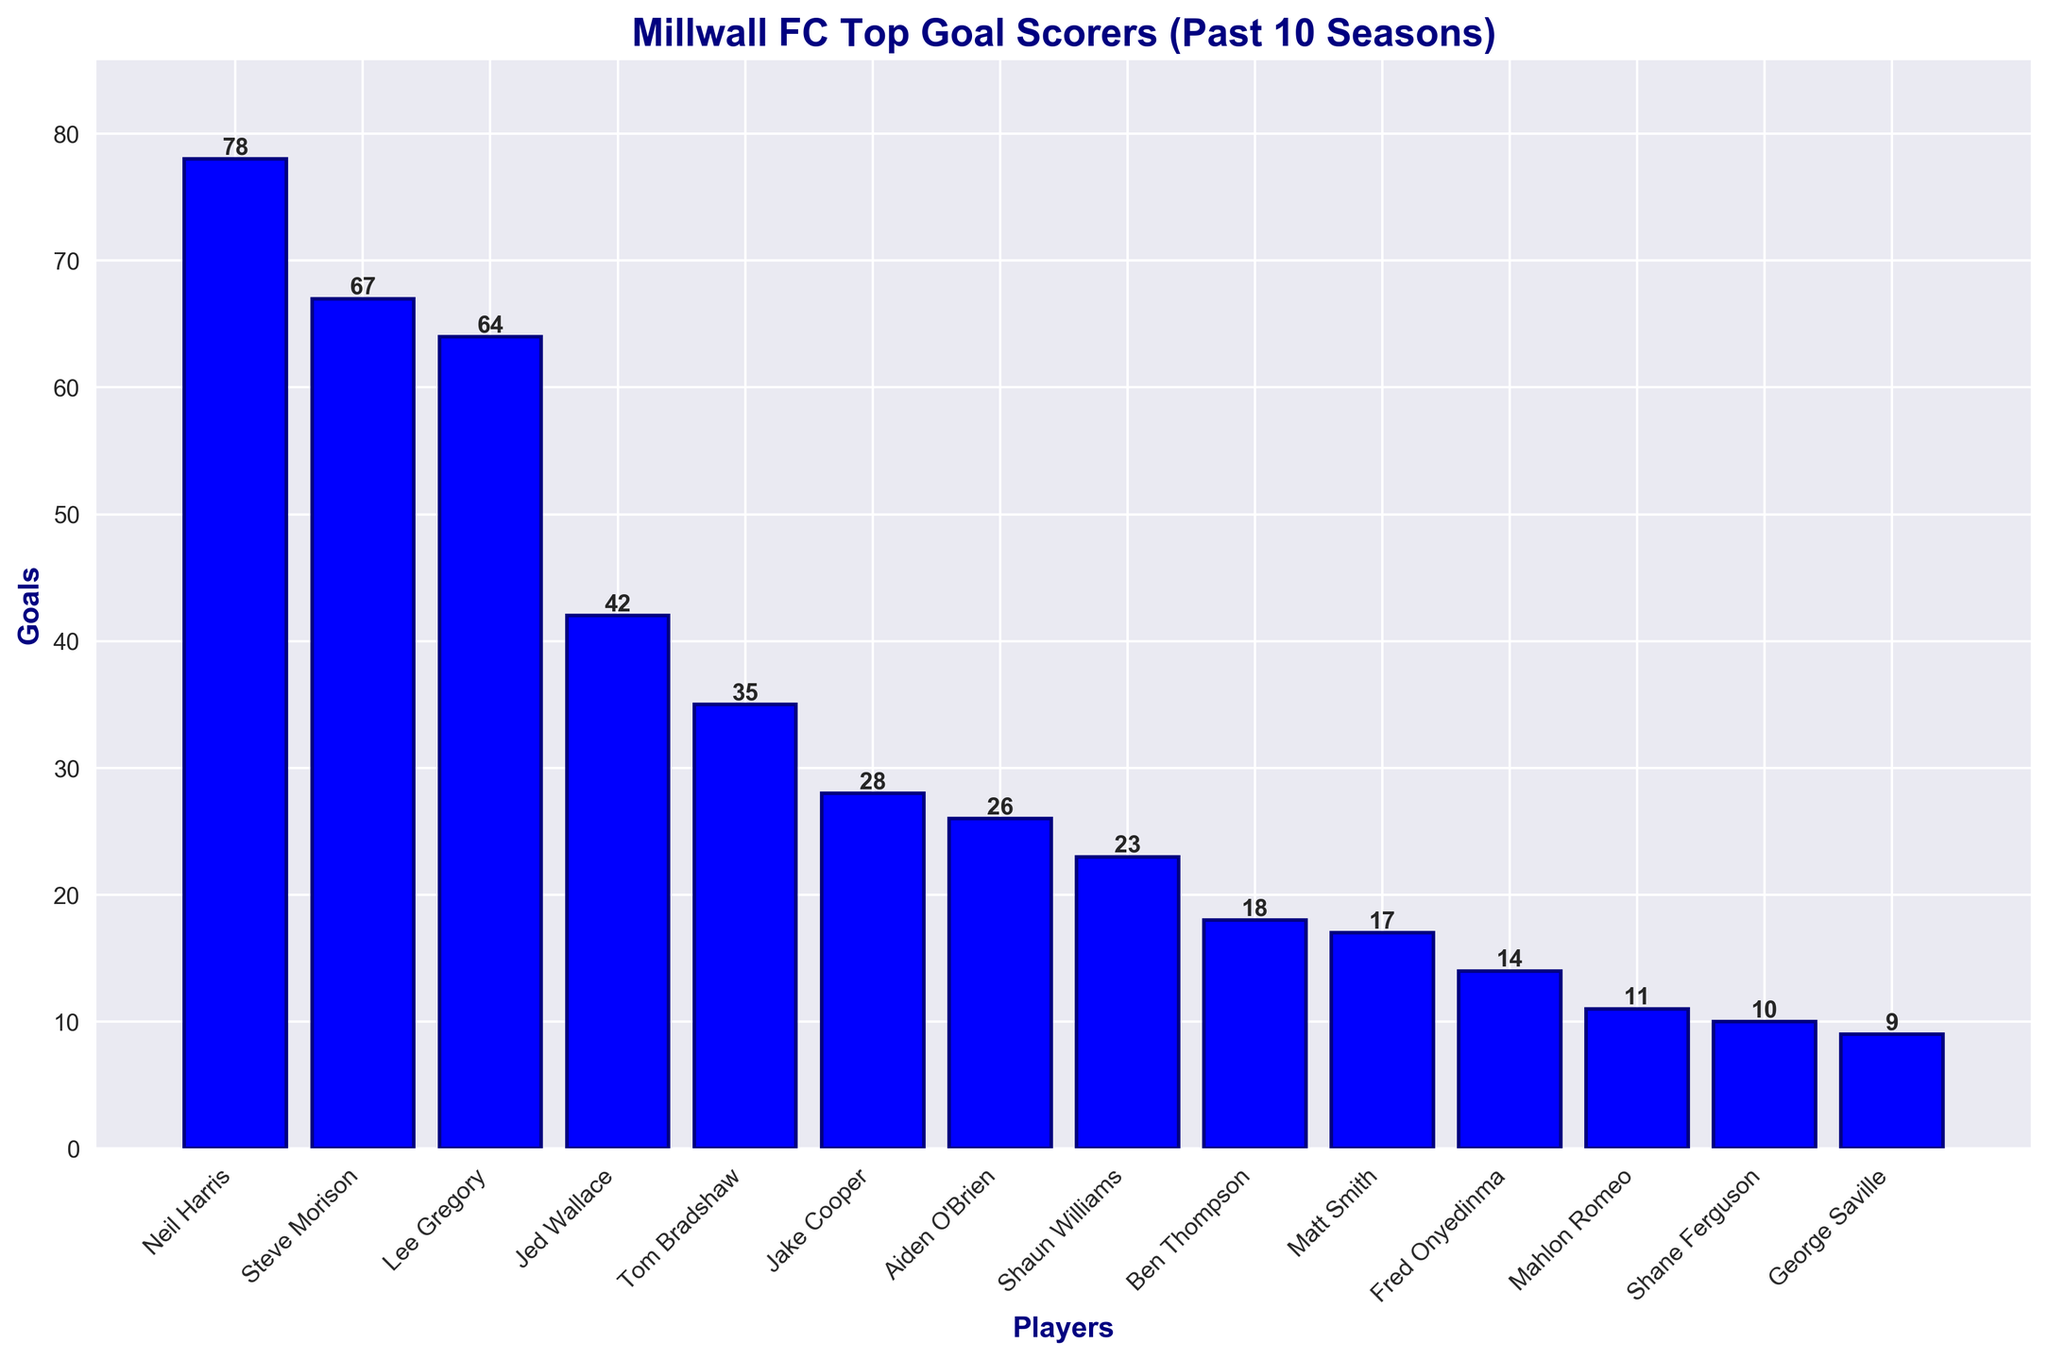What is the total number of goals scored by the top three goal scorers? To find the total number of goals scored by the top three goal scorers, sum the goals of Neil Harris, Steve Morison, and Lee Gregory: 78 + 67 + 64 = 209
Answer: 209 Who is the top goal scorer? The top goal scorer is the player with the highest bar. Neil Harris has the tallest bar with 78 goals.
Answer: Neil Harris How many goals does the player with the second-highest goals score compared to the fourth-highest? The second-highest scorer, Steve Morison, scored 67 goals, and the fourth-highest scorer, Jed Wallace, scored 42 goals. The difference is 67 - 42 = 25.
Answer: 25 What is the average number of goals scored by the players listed? Sum the goals scored by all players and divide by the number of players. Total goals: 78 + 67 + 64 + 42 + 35 + 28 + 26 + 23 + 18 + 17 + 14 + 11 + 10 + 9 = 442. Number of players: 14. Average = 442 / 14 = 31.57
Answer: 31.57 Which players scored fewer than 20 goals? From the bar chart, the players who scored fewer than 20 goals are Ben Thompson, Matt Smith, Fred Onyedinma, Mahlon Romeo, Shane Ferguson, and George Saville.
Answer: Ben Thompson, Matt Smith, Fred Onyedinma, Mahlon Romeo, Shane Ferguson, George Saville What is the difference in the number of goals between the players with the third-highest and the sixth-highest scores? The third-highest scorer, Lee Gregory, has 64 goals, and the sixth-highest scorer, Jake Cooper, has 28 goals. The difference is 64 - 28 = 36.
Answer: 36 Which player's bar is just to the right of Neil Harris in the plot? The bar just to the right of Neil Harris's bar represents Steve Morison, who scored 67 goals.
Answer: Steve Morison How many players scored more than 50 goals? By inspecting the bars, the players who scored more than 50 goals are Neil Harris, Steve Morison, and Lee Gregory. There are 3 players.
Answer: 3 What is the range of goals scored by the players? The range is the difference between the highest and lowest goal counts. The highest is 78 (Neil Harris) and the lowest is 9 (George Saville). Range = 78 - 9 = 69
Answer: 69 